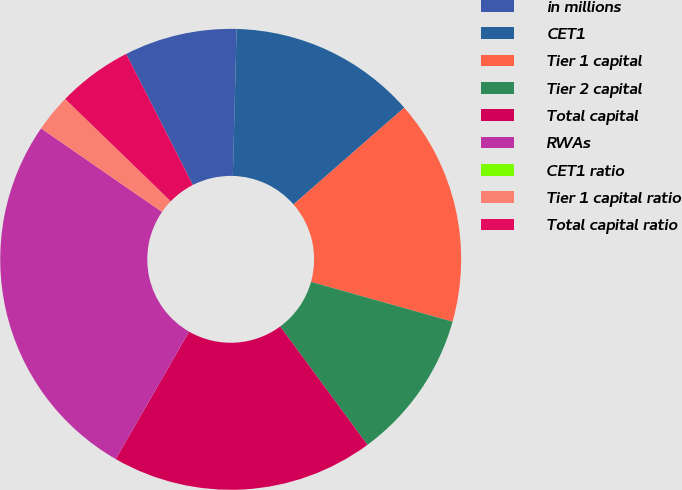<chart> <loc_0><loc_0><loc_500><loc_500><pie_chart><fcel>in millions<fcel>CET1<fcel>Tier 1 capital<fcel>Tier 2 capital<fcel>Total capital<fcel>RWAs<fcel>CET1 ratio<fcel>Tier 1 capital ratio<fcel>Total capital ratio<nl><fcel>7.9%<fcel>13.16%<fcel>15.79%<fcel>10.53%<fcel>18.42%<fcel>26.31%<fcel>0.0%<fcel>2.63%<fcel>5.26%<nl></chart> 